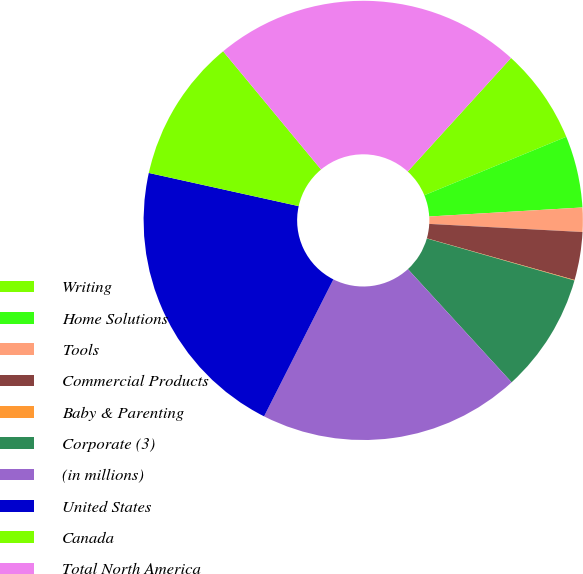Convert chart to OTSL. <chart><loc_0><loc_0><loc_500><loc_500><pie_chart><fcel>Writing<fcel>Home Solutions<fcel>Tools<fcel>Commercial Products<fcel>Baby & Parenting<fcel>Corporate (3)<fcel>(in millions)<fcel>United States<fcel>Canada<fcel>Total North America<nl><fcel>7.03%<fcel>5.28%<fcel>1.78%<fcel>3.53%<fcel>0.04%<fcel>8.78%<fcel>19.26%<fcel>21.01%<fcel>10.52%<fcel>22.76%<nl></chart> 